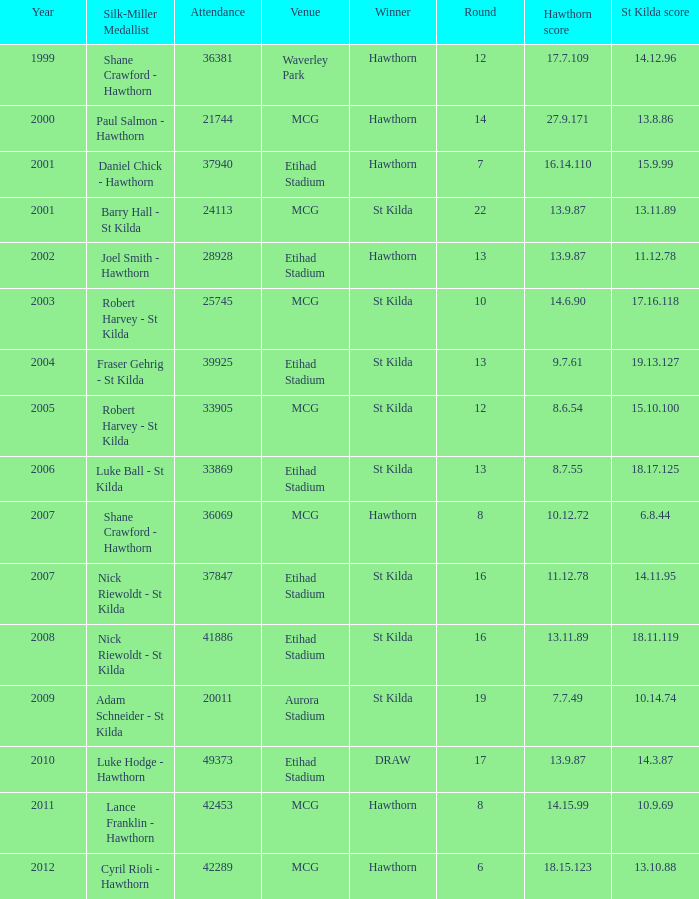What is the attendance when the hawthorn score is 18.15.123? 42289.0. 